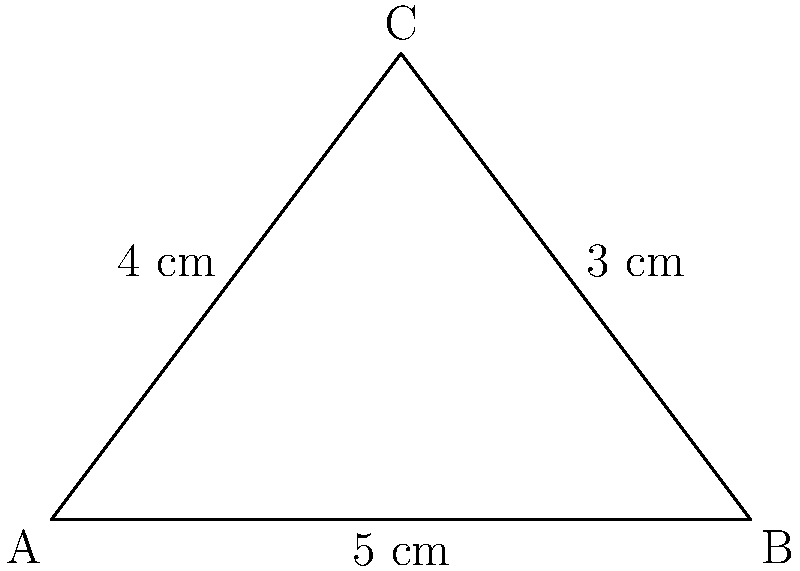A triangular food package has side lengths of 3 cm, 4 cm, and 5 cm. Calculate the angle (in degrees) opposite the 5 cm side to determine if this packaging design affects the preservation of nutrients. Round your answer to the nearest degree. To solve this problem, we'll use the law of cosines. The steps are as follows:

1) The law of cosines states: $c^2 = a^2 + b^2 - 2ab \cos(C)$, where $C$ is the angle opposite side $c$.

2) In this case, we want to find the angle opposite the 5 cm side. Let's call this angle $C$. So:
   $a = 3$ cm, $b = 4$ cm, and $c = 5$ cm

3) Substituting into the formula:
   $5^2 = 3^2 + 4^2 - 2(3)(4) \cos(C)$

4) Simplify:
   $25 = 9 + 16 - 24 \cos(C)$
   $25 = 25 - 24 \cos(C)$

5) Subtract 25 from both sides:
   $0 = -24 \cos(C)$

6) Divide both sides by -24:
   $\cos(C) = 0$

7) Take the inverse cosine (arccos) of both sides:
   $C = \arccos(0)$

8) Calculate:
   $C \approx 90^\circ$

Therefore, the angle opposite the 5 cm side is approximately 90°.
Answer: 90° 